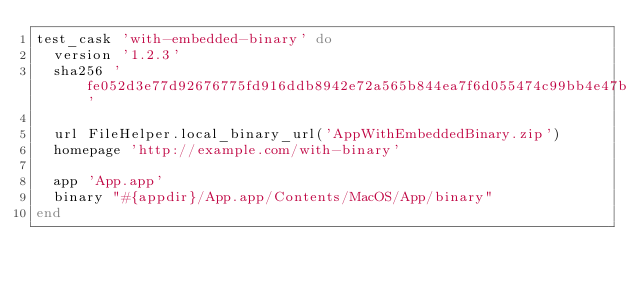<code> <loc_0><loc_0><loc_500><loc_500><_Ruby_>test_cask 'with-embedded-binary' do
  version '1.2.3'
  sha256 'fe052d3e77d92676775fd916ddb8942e72a565b844ea7f6d055474c99bb4e47b'

  url FileHelper.local_binary_url('AppWithEmbeddedBinary.zip')
  homepage 'http://example.com/with-binary'

  app 'App.app'
  binary "#{appdir}/App.app/Contents/MacOS/App/binary"
end
</code> 